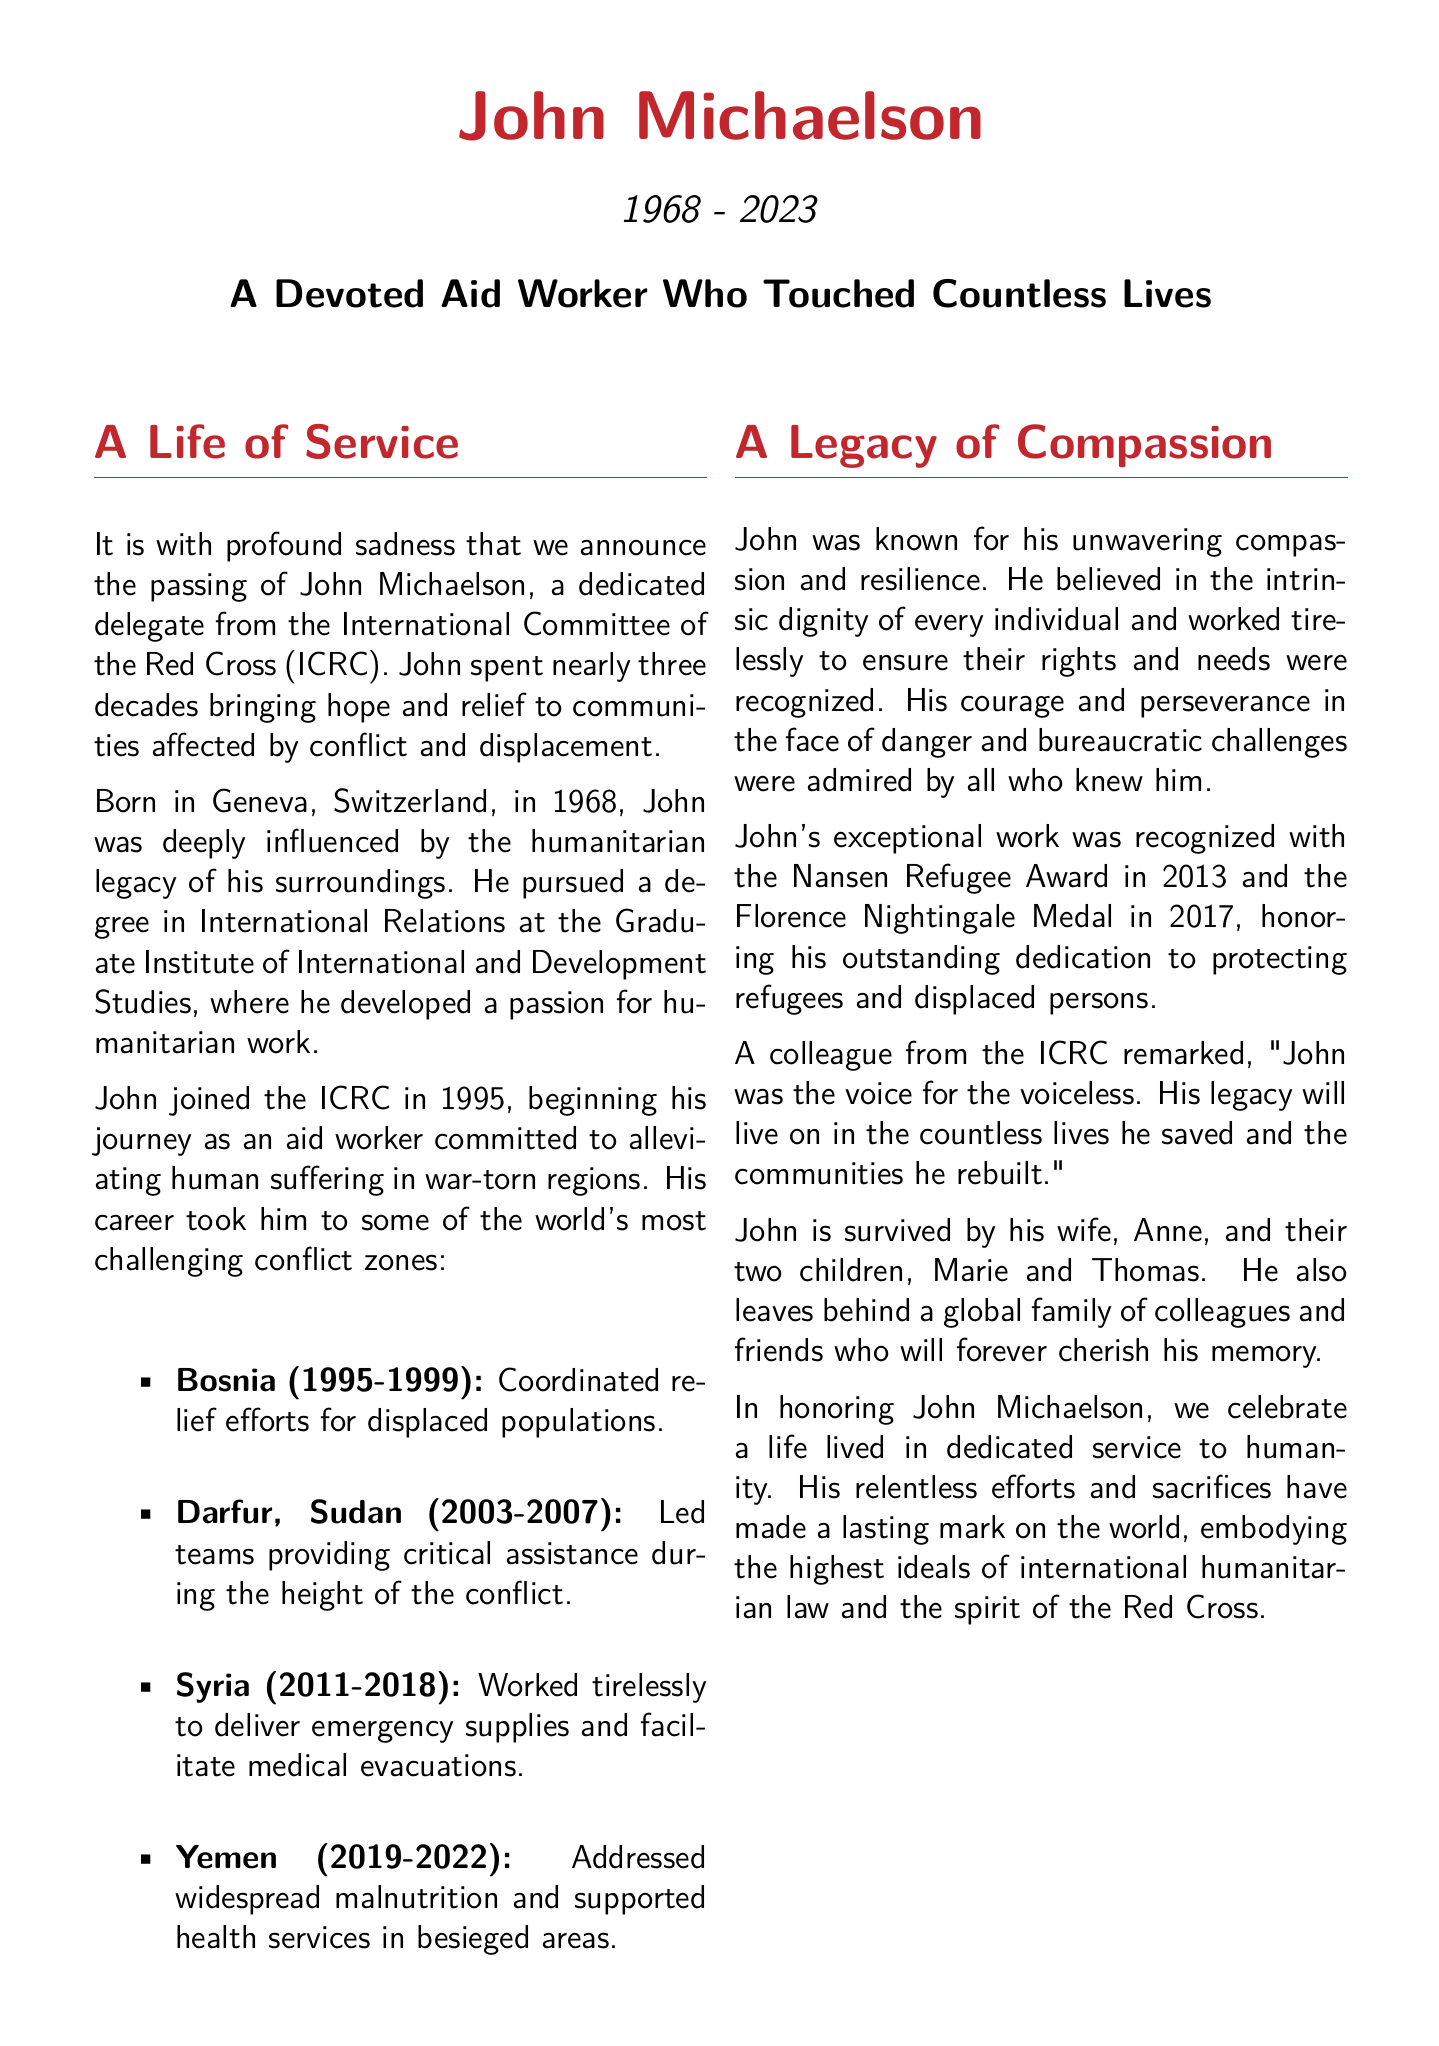What is the name of the aid worker? The aid worker is the focus of the obituary, whose name is explicitly mentioned at the beginning.
Answer: John Michaelson In what year was John born? The obituary provides John Michaelson's birth year mentioned in the introductory section.
Answer: 1968 What organization was John associated with? The document specifies the organization that John dedicated his work to during his career in relief efforts.
Answer: International Committee of the Red Cross In which conflict zone did John work from 2011 to 2018? The specific location where John worked during these years is stated in the list of conflict zones he was involved in.
Answer: Syria What award did John receive in 2013? The obituary lists specific awards that John received in recognition of his humanitarian work.
Answer: Nansen Refugee Award What was the main focus of John's work in Yemen? The obituary describes the issues John addressed while working in Yemen, requiring reasoning about the context of his mission.
Answer: Widespread malnutrition Who survived John Michaelson? The obituary mentions John's family members who are still alive after his passing.
Answer: Anne, Marie, and Thomas What is one quality John was known for? The document specifies characteristics associated with John's personality and work ethic that made him stand out.
Answer: Compassion What does the quote in the document highlight about John's legacy? The quote encapsulates the impact of John's work beyond physical aid, requiring a deeper understanding of the sentiments expressed.
Answer: Hope 